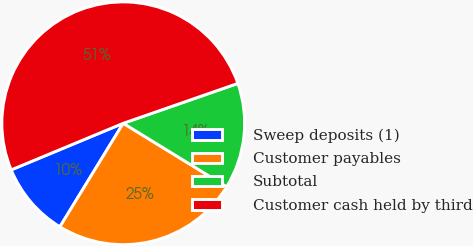Convert chart to OTSL. <chart><loc_0><loc_0><loc_500><loc_500><pie_chart><fcel>Sweep deposits (1)<fcel>Customer payables<fcel>Subtotal<fcel>Customer cash held by third<nl><fcel>9.99%<fcel>24.98%<fcel>14.09%<fcel>50.95%<nl></chart> 